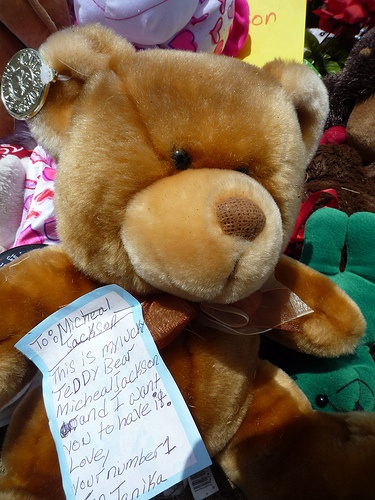Describe the objects in this image and their specific colors. I can see a teddy bear in maroon, black, olive, and white tones in this image. 